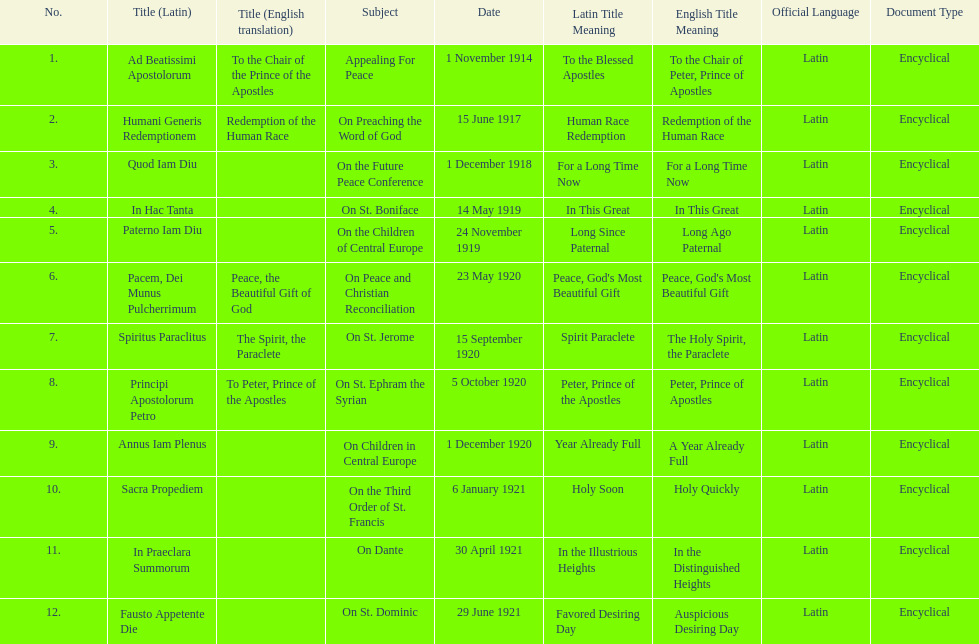Other than january how many encyclicals were in 1921? 2. 